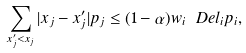<formula> <loc_0><loc_0><loc_500><loc_500>\sum _ { x ^ { \prime } _ { j } < x _ { j } } | x _ { j } - x ^ { \prime } _ { j } | p _ { j } \leq ( 1 - \alpha ) w _ { i } \ D e l _ { i } p _ { i } ,</formula> 